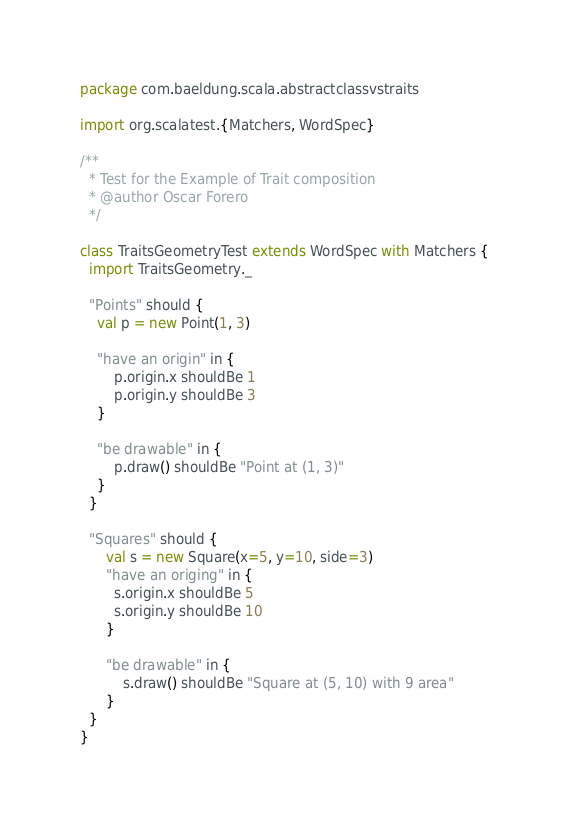Convert code to text. <code><loc_0><loc_0><loc_500><loc_500><_Scala_>package com.baeldung.scala.abstractclassvstraits

import org.scalatest.{Matchers, WordSpec}

/**
  * Test for the Example of Trait composition
  * @author Oscar Forero
  */

class TraitsGeometryTest extends WordSpec with Matchers {
  import TraitsGeometry._

  "Points" should {
    val p = new Point(1, 3)  
    
    "have an origin" in {
        p.origin.x shouldBe 1
        p.origin.y shouldBe 3
    }

    "be drawable" in {
        p.draw() shouldBe "Point at (1, 3)"
    }
  }

  "Squares" should {
      val s = new Square(x=5, y=10, side=3)
      "have an origing" in {
        s.origin.x shouldBe 5
        s.origin.y shouldBe 10
      }

      "be drawable" in {
          s.draw() shouldBe "Square at (5, 10) with 9 area"
      }
  }
}
</code> 